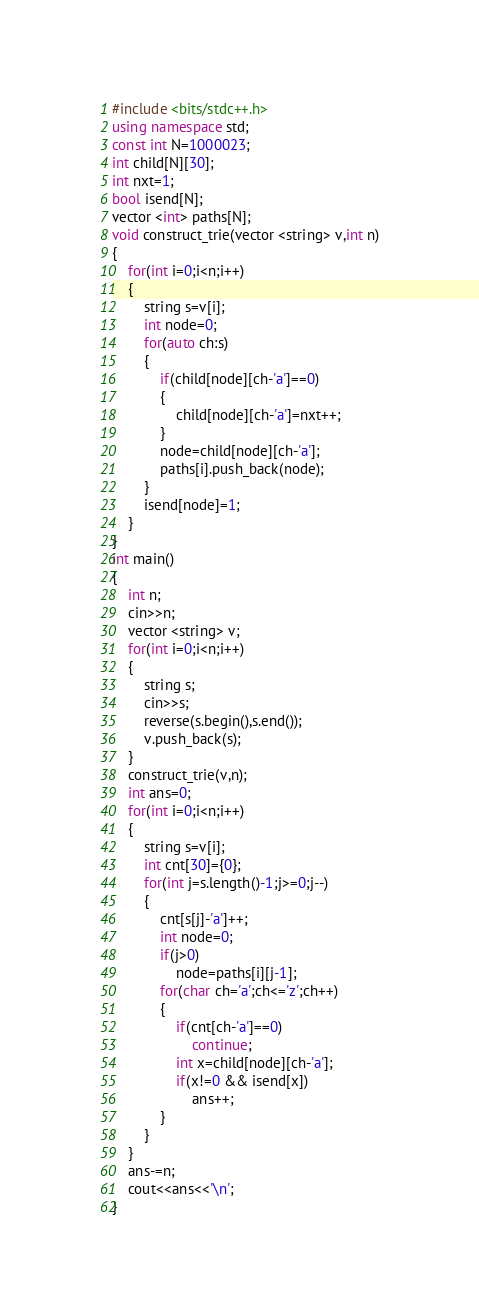Convert code to text. <code><loc_0><loc_0><loc_500><loc_500><_C++_>#include <bits/stdc++.h>
using namespace std;
const int N=1000023;
int child[N][30];
int nxt=1;
bool isend[N];
vector <int> paths[N];
void construct_trie(vector <string> v,int n)
{
    for(int i=0;i<n;i++)
    {
        string s=v[i];
        int node=0;
        for(auto ch:s)
        {
            if(child[node][ch-'a']==0)
            {
                child[node][ch-'a']=nxt++;
            }
            node=child[node][ch-'a'];
            paths[i].push_back(node);
        }
        isend[node]=1;
    }
}
int main()
{
    int n;
    cin>>n;
    vector <string> v;
    for(int i=0;i<n;i++)
    {
        string s;
        cin>>s;
        reverse(s.begin(),s.end());
        v.push_back(s);
    }
    construct_trie(v,n);
    int ans=0;
    for(int i=0;i<n;i++)
    {
        string s=v[i];
        int cnt[30]={0};
        for(int j=s.length()-1;j>=0;j--)
        {
            cnt[s[j]-'a']++;
            int node=0;
            if(j>0)
                node=paths[i][j-1];
            for(char ch='a';ch<='z';ch++)
            {
                if(cnt[ch-'a']==0)
                    continue;
                int x=child[node][ch-'a'];
                if(x!=0 && isend[x])
                    ans++;
            }
        }
    }
    ans-=n;
    cout<<ans<<'\n';
}</code> 